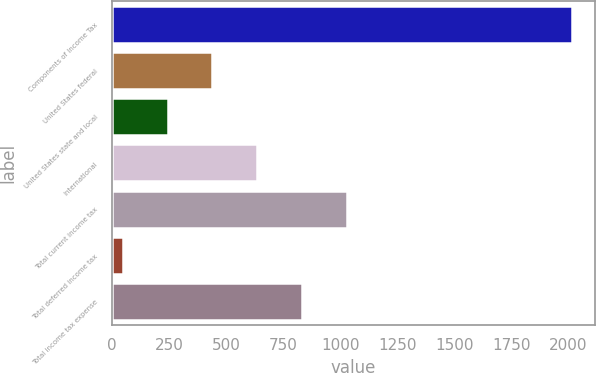Convert chart to OTSL. <chart><loc_0><loc_0><loc_500><loc_500><bar_chart><fcel>Components of Income Tax<fcel>United States federal<fcel>United States state and local<fcel>International<fcel>Total current income tax<fcel>Total deferred income tax<fcel>Total income tax expense<nl><fcel>2016<fcel>440<fcel>243<fcel>637<fcel>1031<fcel>46<fcel>834<nl></chart> 